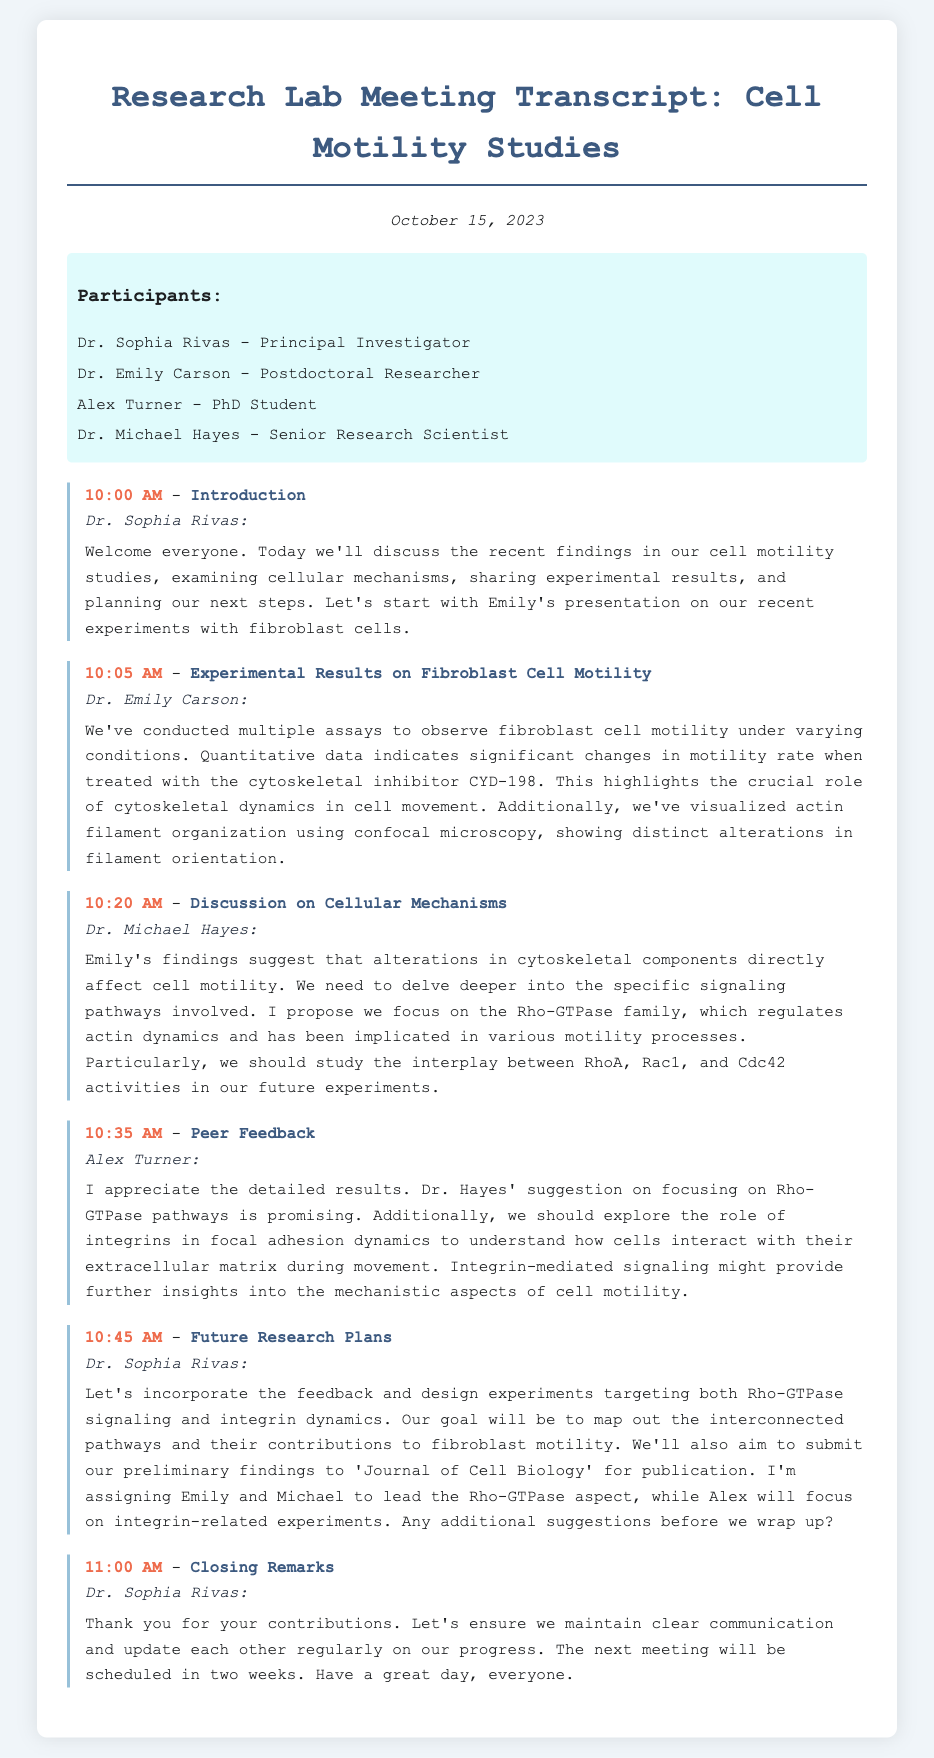What is the date of the lab meeting? The date is mentioned at the beginning of the document as "October 15, 2023."
Answer: October 15, 2023 Who presented the experimental results on fibroblast cell motility? The document states that Dr. Emily Carson presented the experimental results.
Answer: Dr. Emily Carson What inhibitor was used in the fibroblast cell motility experiments? The document mentions the cytoskeletal inhibitor as "CYD-198."
Answer: CYD-198 What family of proteins did Dr. Michael Hayes suggest studying? The suggestion made refers to the "Rho-GTPase family."
Answer: Rho-GTPase family Which dynamics did Alex Turner propose to explore further? Alex Turner suggested to explore "integrin-mediated signaling."
Answer: integrin-mediated signaling What publication is the lab aiming to submit their findings to? The document states they aim to submit to the "Journal of Cell Biology."
Answer: Journal of Cell Biology Who will focus on integrin-related experiments in the future research plans? The document indicates that Alex will focus on integrin-related experiments.
Answer: Alex How long is it until the next meeting is scheduled? The document mentions the next meeting will be scheduled in two weeks.
Answer: two weeks 